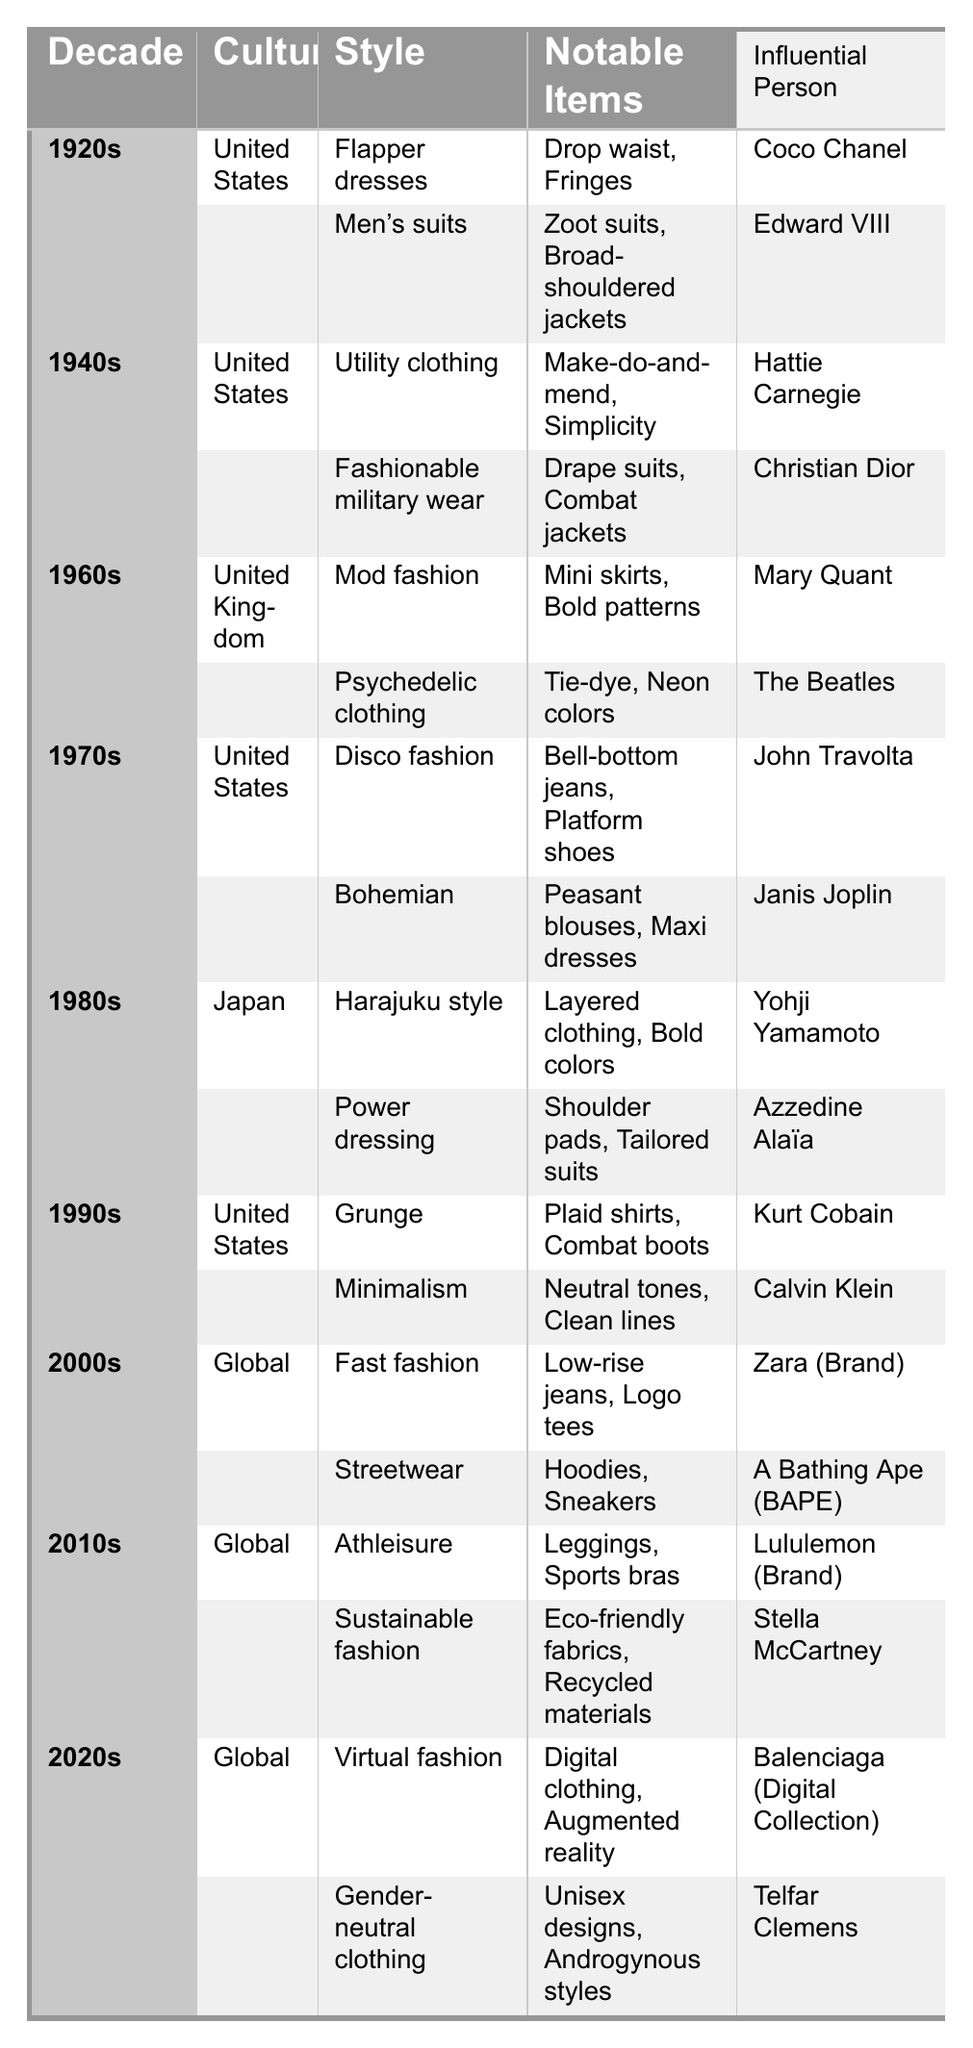What significant fashion trend emerged in the 1920s in the United States? According to the table, the significant trend was "Flapper dresses," which included notable items like "Drop waist" and "Fringes."
Answer: Flapper dresses Which influential person is associated with men's suits in the 1920s? The table states that Edward VIII is the influential person associated with men's suits during the 1920s.
Answer: Edward VIII In what decade did the United States popularize utility clothing? The data indicates that utility clothing was popular in the 1940s in the United States.
Answer: 1940s How many fashion trends are listed for the 1980s in Japan? The table shows that there are two fashion trends listed for the 1980s: "Harajuku style" and "Power dressing."
Answer: 2 Which decade featured both sustainable fashion and athleisure trends? The table shows that both sustainable fashion and athleisure were featured in the 2010s.
Answer: 2010s Was John Travolta an influential person during the 1970s for disco fashion? Yes, the table confirms that John Travolta is listed as an influential person for disco fashion in the 1970s.
Answer: Yes Identify the notable items from the 1960s United Kingdom's Mod fashion. The table lists "Mini skirts" and "Bold patterns" as the notable items from the Mod fashion trend in the 1960s.
Answer: Mini skirts, Bold patterns What is the trend associated with Kurt Cobain in the 1990s? The table indicates that Kurt Cobain is associated with the "Grunge" trend in the 1990s.
Answer: Grunge How many cultures are represented in the table across all decades? The table lists three distinct cultures: United States, United Kingdom, and Japan, and a global category. Counting these gives a total of four cultures.
Answer: 4 What notable items characterize the Gender-neutral clothing of the 2020s? The notable items for Gender-neutral clothing in the 2020s are "Unisex designs" and "Androgynous styles," as per the table contents.
Answer: Unisex designs, Androgynous styles What is the most recent fashion trend listed in the table, and who is the influential person related to it? The most recent trend listed is "Gender-neutral clothing," and the influential person is Telfar Clemens.
Answer: Gender-neutral clothing, Telfar Clemens Which decade had fast fashion as a significant trend, and what was the associated influential brand? The table indicates that fast fashion was significant in the 2000s, and the influential brand associated with it is Zara.
Answer: 2000s, Zara Which influential person appears alongside sustainable fashion? The table lists Stella McCartney as the influential person associated with sustainable fashion.
Answer: Stella McCartney Can you name any two styles that were popular during the 1970s in the United States? The table specifies that "Disco fashion" and "Bohemian" were popular styles during the 1970s in the United States.
Answer: Disco fashion, Bohemian How did the fashion trend of the 1960s reflect cultural changes through its notable items? The 1960s Mod fashion with notable items like "Mini skirts" and the Psychedelic clothing trend featuring "Tie-dye" and "Neon colors" reflected significant cultural changes in youth, freedom, and expression.
Answer: Youth and expression 